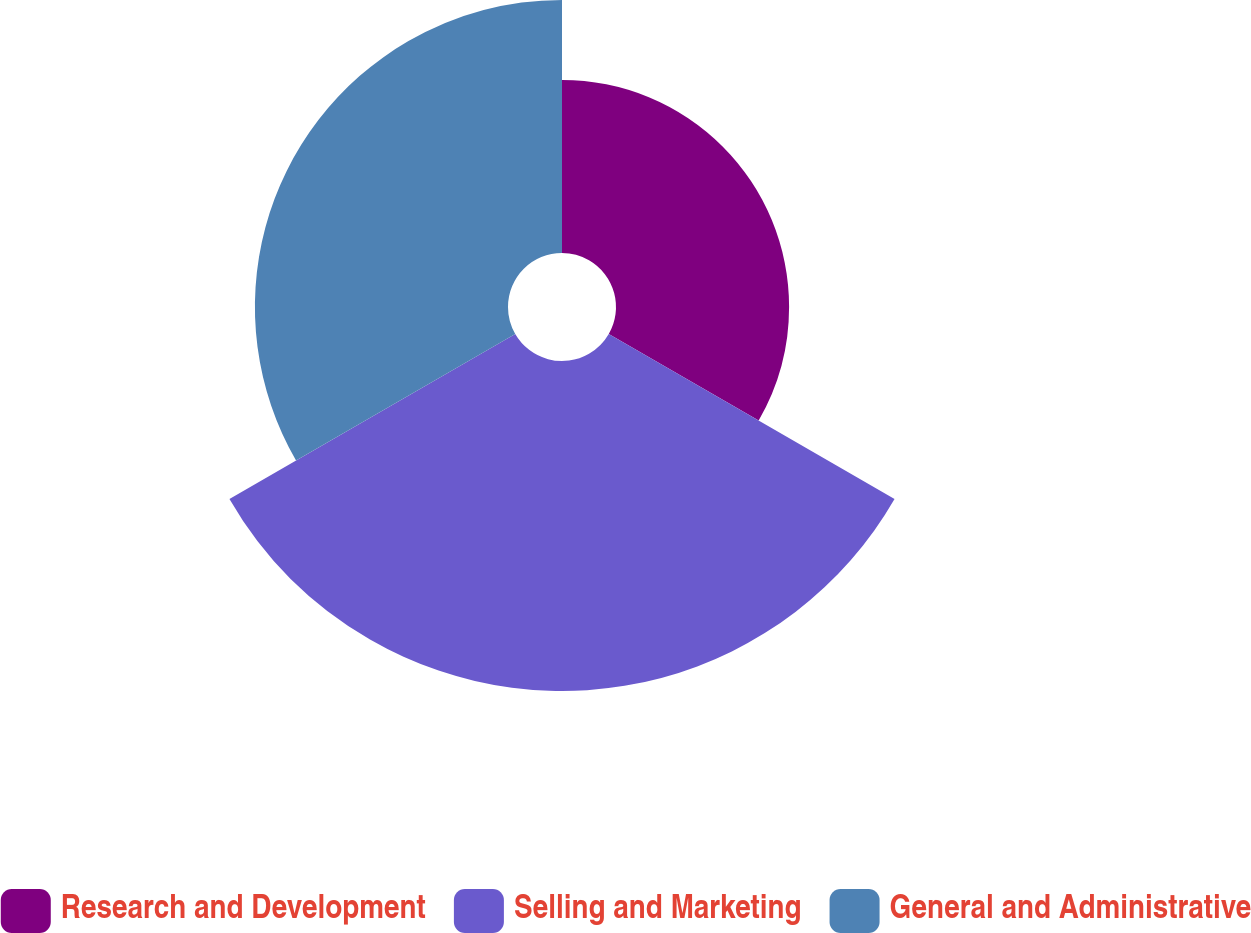Convert chart. <chart><loc_0><loc_0><loc_500><loc_500><pie_chart><fcel>Research and Development<fcel>Selling and Marketing<fcel>General and Administrative<nl><fcel>22.89%<fcel>43.64%<fcel>33.47%<nl></chart> 